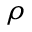<formula> <loc_0><loc_0><loc_500><loc_500>\rho</formula> 